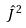Convert formula to latex. <formula><loc_0><loc_0><loc_500><loc_500>\hat { J } ^ { 2 }</formula> 